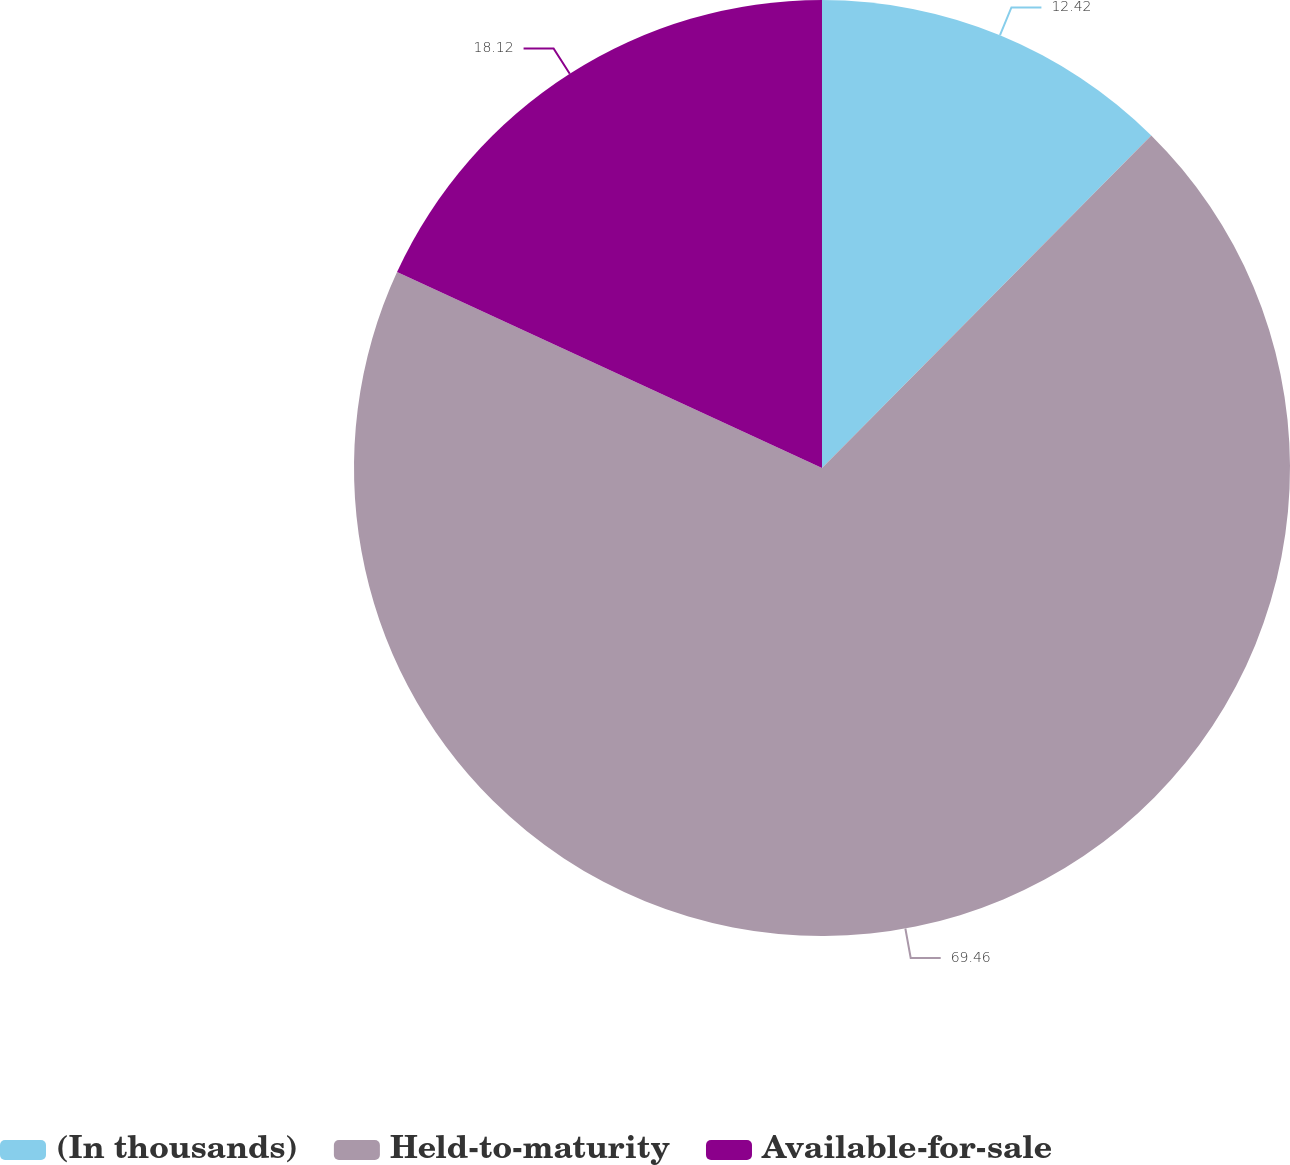Convert chart to OTSL. <chart><loc_0><loc_0><loc_500><loc_500><pie_chart><fcel>(In thousands)<fcel>Held-to-maturity<fcel>Available-for-sale<nl><fcel>12.42%<fcel>69.46%<fcel>18.12%<nl></chart> 